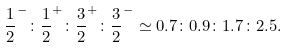<formula> <loc_0><loc_0><loc_500><loc_500>\frac { 1 } { 2 } ^ { - } \colon \frac { 1 } { 2 } ^ { + } \colon \frac { 3 } { 2 } ^ { + } \colon \frac { 3 } { 2 } ^ { - } \simeq 0 . 7 \colon 0 . 9 \colon 1 . 7 \colon 2 . 5 .</formula> 